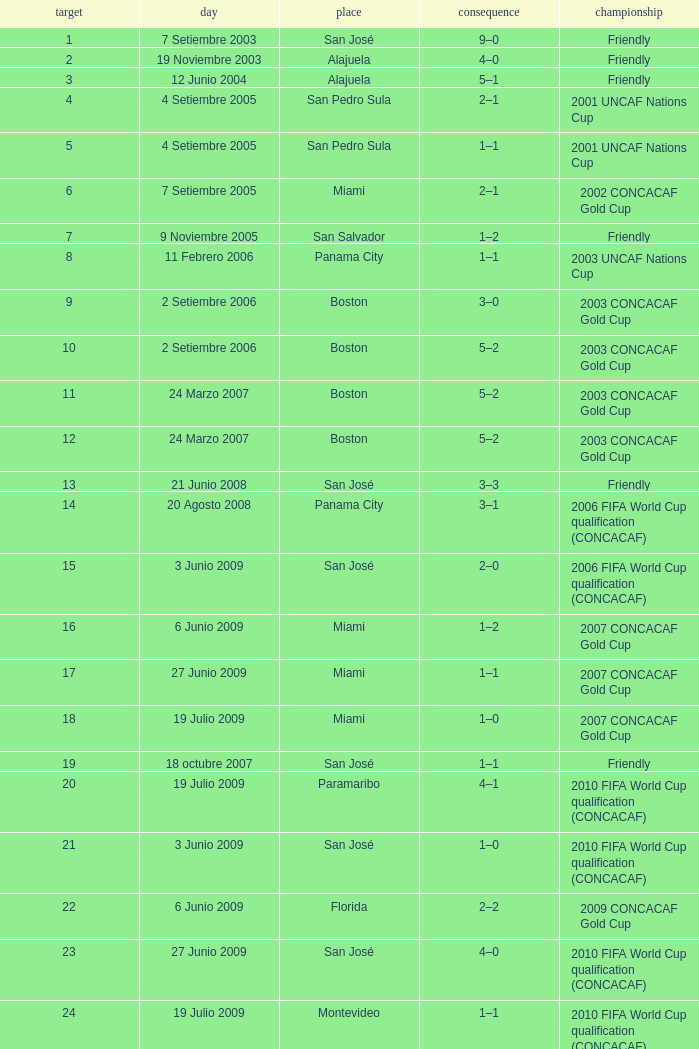At the venue of panama city, on 11 Febrero 2006, how many goals were scored? 1.0. 